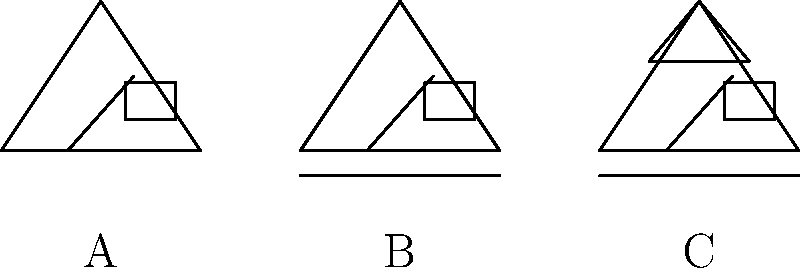Looking at the simple house sketches above, which type of house (A, B, or C) would you identify as a bungalow with a front porch? Let's examine each house sketch step-by-step:

1. House A:
   - Has a simple triangular roof
   - Has a door and window
   - Does not have a front porch

2. House B:
   - Has a simple triangular roof
   - Has a door and window
   - Has a front porch (indicated by the horizontal line at the bottom)

3. House C:
   - Has a more complex roof structure with a gable (small triangle on the roof)
   - Has a door and window
   - Has a front porch (indicated by the horizontal line at the bottom)

A bungalow is typically a single-story house with a simple design. The key feature we're looking for in this question is the front porch.

House B matches the description of a bungalow with a front porch because:
- It has a simple roof structure (unlike House C with its gable)
- It clearly shows a front porch (unlike House A)

Therefore, House B best represents a bungalow with a front porch.
Answer: B 